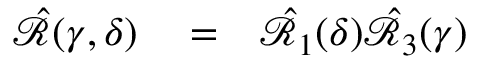Convert formula to latex. <formula><loc_0><loc_0><loc_500><loc_500>\begin{array} { r l r } { \hat { \mathcal { R } } ( \gamma , \delta ) } & = } & { \hat { \mathcal { R } } _ { 1 } ( \delta ) \hat { \mathcal { R } } _ { 3 } ( \gamma ) } \end{array}</formula> 